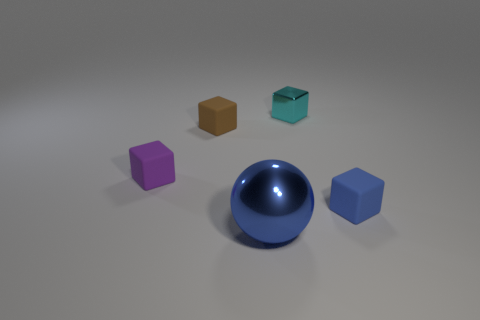Subtract all tiny rubber blocks. How many blocks are left? 1 Add 5 purple objects. How many objects exist? 10 Subtract all cyan blocks. How many blocks are left? 3 Subtract all spheres. How many objects are left? 4 Subtract 2 cubes. How many cubes are left? 2 Subtract all cyan balls. Subtract all yellow cylinders. How many balls are left? 1 Subtract all brown metallic cylinders. Subtract all blue shiny balls. How many objects are left? 4 Add 3 cyan cubes. How many cyan cubes are left? 4 Add 4 rubber things. How many rubber things exist? 7 Subtract 0 red balls. How many objects are left? 5 